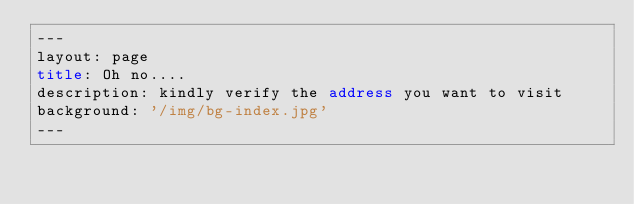Convert code to text. <code><loc_0><loc_0><loc_500><loc_500><_HTML_>---
layout: page
title: Oh no....
description: kindly verify the address you want to visit
background: '/img/bg-index.jpg'
---
</code> 